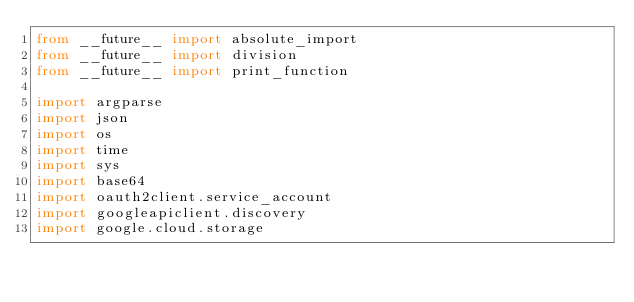<code> <loc_0><loc_0><loc_500><loc_500><_Python_>from __future__ import absolute_import
from __future__ import division
from __future__ import print_function

import argparse
import json
import os
import time
import sys
import base64
import oauth2client.service_account
import googleapiclient.discovery
import google.cloud.storage

</code> 